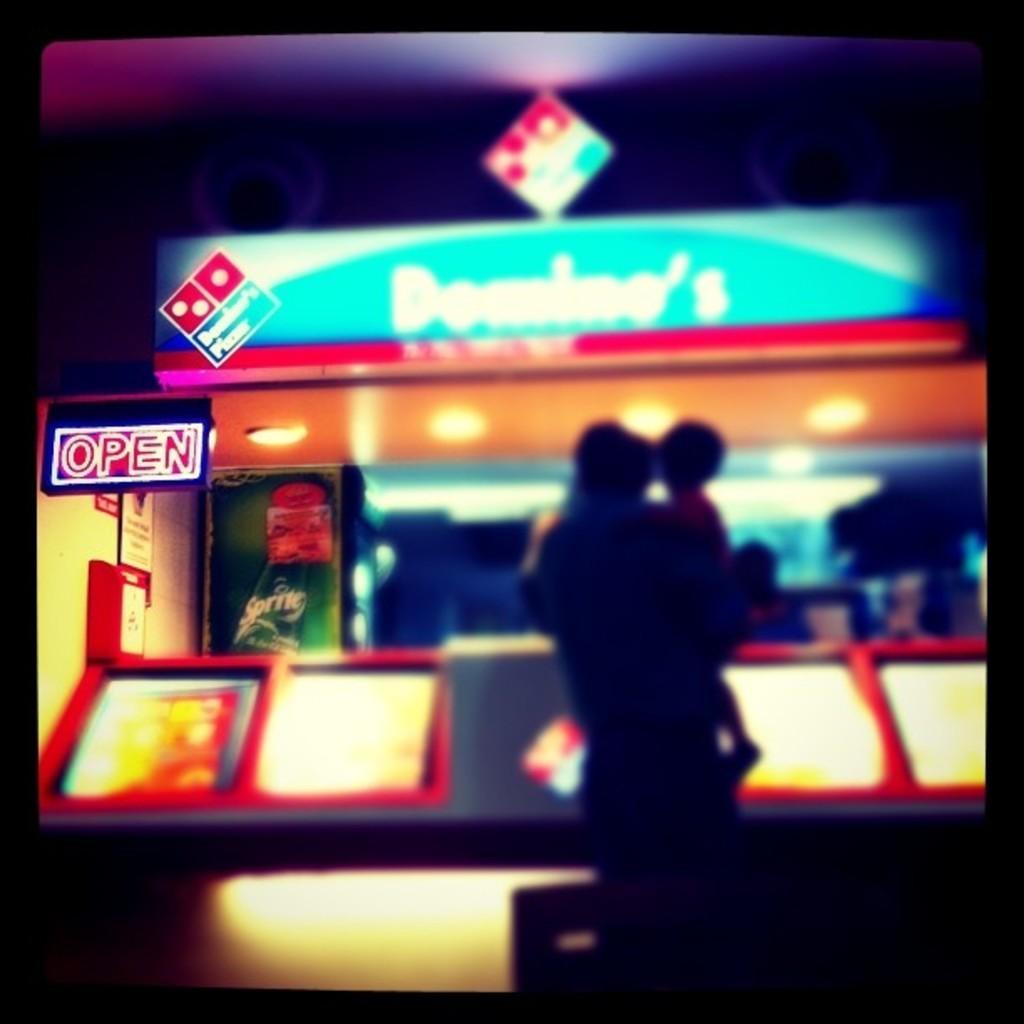How would you summarize this image in a sentence or two? In the middle of this image, there is a person, holding a baby and standing. In the background, there is a shop having a hoarding and lights and there are other objects. 